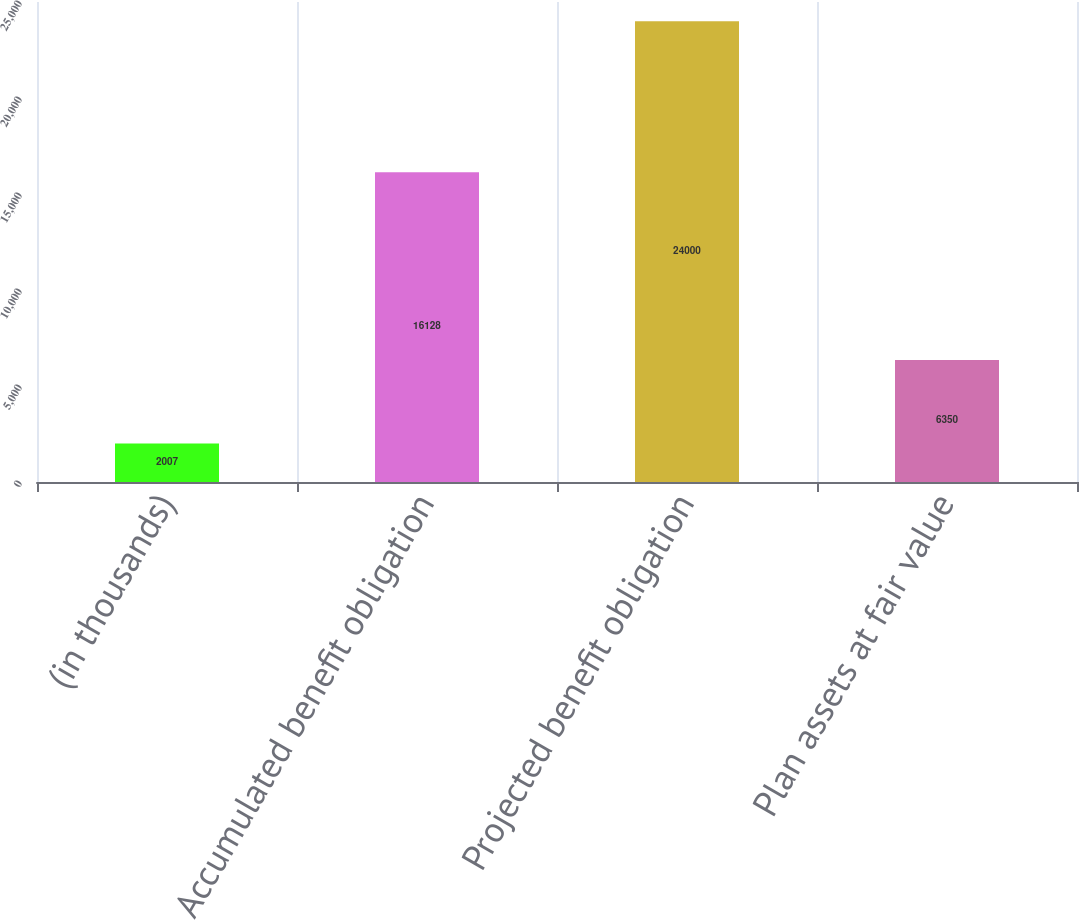<chart> <loc_0><loc_0><loc_500><loc_500><bar_chart><fcel>(in thousands)<fcel>Accumulated benefit obligation<fcel>Projected benefit obligation<fcel>Plan assets at fair value<nl><fcel>2007<fcel>16128<fcel>24000<fcel>6350<nl></chart> 